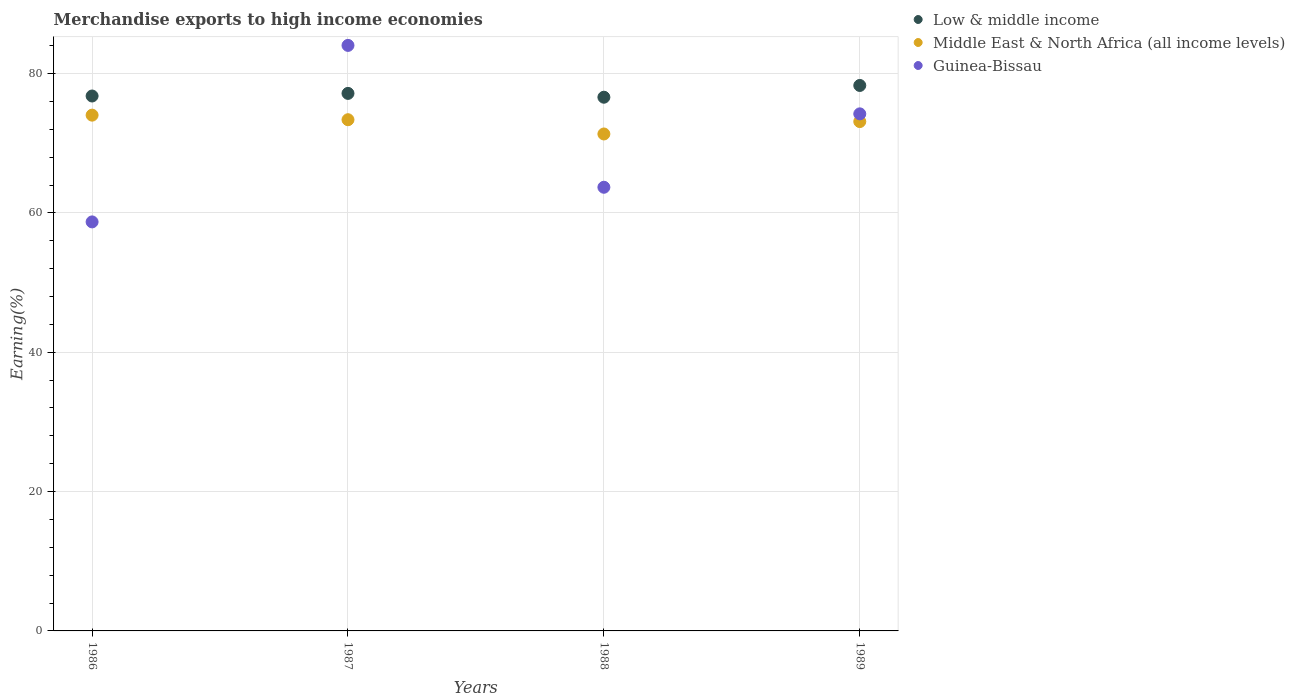How many different coloured dotlines are there?
Offer a very short reply. 3. What is the percentage of amount earned from merchandise exports in Guinea-Bissau in 1986?
Keep it short and to the point. 58.71. Across all years, what is the maximum percentage of amount earned from merchandise exports in Low & middle income?
Give a very brief answer. 78.29. Across all years, what is the minimum percentage of amount earned from merchandise exports in Middle East & North Africa (all income levels)?
Ensure brevity in your answer.  71.33. In which year was the percentage of amount earned from merchandise exports in Middle East & North Africa (all income levels) maximum?
Keep it short and to the point. 1986. What is the total percentage of amount earned from merchandise exports in Low & middle income in the graph?
Provide a succinct answer. 308.84. What is the difference between the percentage of amount earned from merchandise exports in Middle East & North Africa (all income levels) in 1986 and that in 1987?
Make the answer very short. 0.66. What is the difference between the percentage of amount earned from merchandise exports in Guinea-Bissau in 1988 and the percentage of amount earned from merchandise exports in Middle East & North Africa (all income levels) in 1987?
Offer a terse response. -9.7. What is the average percentage of amount earned from merchandise exports in Middle East & North Africa (all income levels) per year?
Offer a very short reply. 72.96. In the year 1987, what is the difference between the percentage of amount earned from merchandise exports in Guinea-Bissau and percentage of amount earned from merchandise exports in Middle East & North Africa (all income levels)?
Ensure brevity in your answer.  10.67. In how many years, is the percentage of amount earned from merchandise exports in Guinea-Bissau greater than 24 %?
Make the answer very short. 4. What is the ratio of the percentage of amount earned from merchandise exports in Low & middle income in 1986 to that in 1987?
Provide a succinct answer. 1. Is the percentage of amount earned from merchandise exports in Low & middle income in 1988 less than that in 1989?
Keep it short and to the point. Yes. What is the difference between the highest and the second highest percentage of amount earned from merchandise exports in Guinea-Bissau?
Make the answer very short. 9.83. What is the difference between the highest and the lowest percentage of amount earned from merchandise exports in Low & middle income?
Your answer should be very brief. 1.69. In how many years, is the percentage of amount earned from merchandise exports in Low & middle income greater than the average percentage of amount earned from merchandise exports in Low & middle income taken over all years?
Provide a succinct answer. 1. Is it the case that in every year, the sum of the percentage of amount earned from merchandise exports in Middle East & North Africa (all income levels) and percentage of amount earned from merchandise exports in Guinea-Bissau  is greater than the percentage of amount earned from merchandise exports in Low & middle income?
Keep it short and to the point. Yes. Does the percentage of amount earned from merchandise exports in Middle East & North Africa (all income levels) monotonically increase over the years?
Your answer should be compact. No. Is the percentage of amount earned from merchandise exports in Guinea-Bissau strictly less than the percentage of amount earned from merchandise exports in Middle East & North Africa (all income levels) over the years?
Provide a short and direct response. No. How many dotlines are there?
Offer a terse response. 3. How many years are there in the graph?
Your answer should be very brief. 4. Are the values on the major ticks of Y-axis written in scientific E-notation?
Your response must be concise. No. Does the graph contain grids?
Give a very brief answer. Yes. Where does the legend appear in the graph?
Your answer should be compact. Top right. How many legend labels are there?
Offer a very short reply. 3. How are the legend labels stacked?
Your response must be concise. Vertical. What is the title of the graph?
Keep it short and to the point. Merchandise exports to high income economies. What is the label or title of the Y-axis?
Keep it short and to the point. Earning(%). What is the Earning(%) in Low & middle income in 1986?
Provide a succinct answer. 76.78. What is the Earning(%) of Middle East & North Africa (all income levels) in 1986?
Provide a succinct answer. 74.03. What is the Earning(%) of Guinea-Bissau in 1986?
Your answer should be very brief. 58.71. What is the Earning(%) of Low & middle income in 1987?
Offer a terse response. 77.16. What is the Earning(%) of Middle East & North Africa (all income levels) in 1987?
Provide a succinct answer. 73.38. What is the Earning(%) of Guinea-Bissau in 1987?
Your response must be concise. 84.04. What is the Earning(%) of Low & middle income in 1988?
Give a very brief answer. 76.61. What is the Earning(%) in Middle East & North Africa (all income levels) in 1988?
Provide a short and direct response. 71.33. What is the Earning(%) of Guinea-Bissau in 1988?
Make the answer very short. 63.68. What is the Earning(%) of Low & middle income in 1989?
Your answer should be very brief. 78.29. What is the Earning(%) of Middle East & North Africa (all income levels) in 1989?
Keep it short and to the point. 73.11. What is the Earning(%) in Guinea-Bissau in 1989?
Your answer should be very brief. 74.22. Across all years, what is the maximum Earning(%) of Low & middle income?
Keep it short and to the point. 78.29. Across all years, what is the maximum Earning(%) of Middle East & North Africa (all income levels)?
Keep it short and to the point. 74.03. Across all years, what is the maximum Earning(%) in Guinea-Bissau?
Offer a terse response. 84.04. Across all years, what is the minimum Earning(%) in Low & middle income?
Provide a short and direct response. 76.61. Across all years, what is the minimum Earning(%) in Middle East & North Africa (all income levels)?
Give a very brief answer. 71.33. Across all years, what is the minimum Earning(%) in Guinea-Bissau?
Keep it short and to the point. 58.71. What is the total Earning(%) in Low & middle income in the graph?
Your answer should be very brief. 308.84. What is the total Earning(%) in Middle East & North Africa (all income levels) in the graph?
Provide a short and direct response. 291.85. What is the total Earning(%) of Guinea-Bissau in the graph?
Provide a short and direct response. 280.65. What is the difference between the Earning(%) of Low & middle income in 1986 and that in 1987?
Your response must be concise. -0.37. What is the difference between the Earning(%) of Middle East & North Africa (all income levels) in 1986 and that in 1987?
Give a very brief answer. 0.66. What is the difference between the Earning(%) in Guinea-Bissau in 1986 and that in 1987?
Your answer should be compact. -25.34. What is the difference between the Earning(%) in Low & middle income in 1986 and that in 1988?
Provide a succinct answer. 0.17. What is the difference between the Earning(%) in Middle East & North Africa (all income levels) in 1986 and that in 1988?
Ensure brevity in your answer.  2.7. What is the difference between the Earning(%) of Guinea-Bissau in 1986 and that in 1988?
Your response must be concise. -4.97. What is the difference between the Earning(%) in Low & middle income in 1986 and that in 1989?
Offer a very short reply. -1.51. What is the difference between the Earning(%) in Middle East & North Africa (all income levels) in 1986 and that in 1989?
Make the answer very short. 0.92. What is the difference between the Earning(%) in Guinea-Bissau in 1986 and that in 1989?
Give a very brief answer. -15.51. What is the difference between the Earning(%) of Low & middle income in 1987 and that in 1988?
Keep it short and to the point. 0.55. What is the difference between the Earning(%) in Middle East & North Africa (all income levels) in 1987 and that in 1988?
Keep it short and to the point. 2.05. What is the difference between the Earning(%) in Guinea-Bissau in 1987 and that in 1988?
Provide a succinct answer. 20.36. What is the difference between the Earning(%) of Low & middle income in 1987 and that in 1989?
Keep it short and to the point. -1.14. What is the difference between the Earning(%) of Middle East & North Africa (all income levels) in 1987 and that in 1989?
Offer a terse response. 0.27. What is the difference between the Earning(%) of Guinea-Bissau in 1987 and that in 1989?
Your answer should be very brief. 9.83. What is the difference between the Earning(%) of Low & middle income in 1988 and that in 1989?
Give a very brief answer. -1.69. What is the difference between the Earning(%) in Middle East & North Africa (all income levels) in 1988 and that in 1989?
Provide a short and direct response. -1.78. What is the difference between the Earning(%) of Guinea-Bissau in 1988 and that in 1989?
Give a very brief answer. -10.54. What is the difference between the Earning(%) in Low & middle income in 1986 and the Earning(%) in Middle East & North Africa (all income levels) in 1987?
Make the answer very short. 3.4. What is the difference between the Earning(%) in Low & middle income in 1986 and the Earning(%) in Guinea-Bissau in 1987?
Provide a short and direct response. -7.26. What is the difference between the Earning(%) of Middle East & North Africa (all income levels) in 1986 and the Earning(%) of Guinea-Bissau in 1987?
Your response must be concise. -10.01. What is the difference between the Earning(%) in Low & middle income in 1986 and the Earning(%) in Middle East & North Africa (all income levels) in 1988?
Provide a short and direct response. 5.45. What is the difference between the Earning(%) of Low & middle income in 1986 and the Earning(%) of Guinea-Bissau in 1988?
Provide a short and direct response. 13.1. What is the difference between the Earning(%) in Middle East & North Africa (all income levels) in 1986 and the Earning(%) in Guinea-Bissau in 1988?
Keep it short and to the point. 10.35. What is the difference between the Earning(%) of Low & middle income in 1986 and the Earning(%) of Middle East & North Africa (all income levels) in 1989?
Your answer should be compact. 3.67. What is the difference between the Earning(%) of Low & middle income in 1986 and the Earning(%) of Guinea-Bissau in 1989?
Keep it short and to the point. 2.56. What is the difference between the Earning(%) in Middle East & North Africa (all income levels) in 1986 and the Earning(%) in Guinea-Bissau in 1989?
Your answer should be very brief. -0.19. What is the difference between the Earning(%) of Low & middle income in 1987 and the Earning(%) of Middle East & North Africa (all income levels) in 1988?
Offer a very short reply. 5.83. What is the difference between the Earning(%) in Low & middle income in 1987 and the Earning(%) in Guinea-Bissau in 1988?
Make the answer very short. 13.47. What is the difference between the Earning(%) in Middle East & North Africa (all income levels) in 1987 and the Earning(%) in Guinea-Bissau in 1988?
Your response must be concise. 9.7. What is the difference between the Earning(%) in Low & middle income in 1987 and the Earning(%) in Middle East & North Africa (all income levels) in 1989?
Offer a terse response. 4.04. What is the difference between the Earning(%) in Low & middle income in 1987 and the Earning(%) in Guinea-Bissau in 1989?
Your response must be concise. 2.94. What is the difference between the Earning(%) of Middle East & North Africa (all income levels) in 1987 and the Earning(%) of Guinea-Bissau in 1989?
Keep it short and to the point. -0.84. What is the difference between the Earning(%) of Low & middle income in 1988 and the Earning(%) of Middle East & North Africa (all income levels) in 1989?
Keep it short and to the point. 3.5. What is the difference between the Earning(%) in Low & middle income in 1988 and the Earning(%) in Guinea-Bissau in 1989?
Your answer should be very brief. 2.39. What is the difference between the Earning(%) in Middle East & North Africa (all income levels) in 1988 and the Earning(%) in Guinea-Bissau in 1989?
Keep it short and to the point. -2.89. What is the average Earning(%) in Low & middle income per year?
Your answer should be compact. 77.21. What is the average Earning(%) of Middle East & North Africa (all income levels) per year?
Your response must be concise. 72.96. What is the average Earning(%) of Guinea-Bissau per year?
Give a very brief answer. 70.16. In the year 1986, what is the difference between the Earning(%) of Low & middle income and Earning(%) of Middle East & North Africa (all income levels)?
Your answer should be compact. 2.75. In the year 1986, what is the difference between the Earning(%) of Low & middle income and Earning(%) of Guinea-Bissau?
Give a very brief answer. 18.07. In the year 1986, what is the difference between the Earning(%) of Middle East & North Africa (all income levels) and Earning(%) of Guinea-Bissau?
Offer a very short reply. 15.32. In the year 1987, what is the difference between the Earning(%) of Low & middle income and Earning(%) of Middle East & North Africa (all income levels)?
Offer a very short reply. 3.78. In the year 1987, what is the difference between the Earning(%) in Low & middle income and Earning(%) in Guinea-Bissau?
Your answer should be very brief. -6.89. In the year 1987, what is the difference between the Earning(%) of Middle East & North Africa (all income levels) and Earning(%) of Guinea-Bissau?
Your response must be concise. -10.67. In the year 1988, what is the difference between the Earning(%) in Low & middle income and Earning(%) in Middle East & North Africa (all income levels)?
Offer a very short reply. 5.28. In the year 1988, what is the difference between the Earning(%) of Low & middle income and Earning(%) of Guinea-Bissau?
Your response must be concise. 12.92. In the year 1988, what is the difference between the Earning(%) in Middle East & North Africa (all income levels) and Earning(%) in Guinea-Bissau?
Keep it short and to the point. 7.65. In the year 1989, what is the difference between the Earning(%) in Low & middle income and Earning(%) in Middle East & North Africa (all income levels)?
Make the answer very short. 5.18. In the year 1989, what is the difference between the Earning(%) in Low & middle income and Earning(%) in Guinea-Bissau?
Your answer should be very brief. 4.08. In the year 1989, what is the difference between the Earning(%) of Middle East & North Africa (all income levels) and Earning(%) of Guinea-Bissau?
Provide a short and direct response. -1.11. What is the ratio of the Earning(%) of Middle East & North Africa (all income levels) in 1986 to that in 1987?
Your answer should be very brief. 1.01. What is the ratio of the Earning(%) in Guinea-Bissau in 1986 to that in 1987?
Give a very brief answer. 0.7. What is the ratio of the Earning(%) in Middle East & North Africa (all income levels) in 1986 to that in 1988?
Your response must be concise. 1.04. What is the ratio of the Earning(%) of Guinea-Bissau in 1986 to that in 1988?
Give a very brief answer. 0.92. What is the ratio of the Earning(%) in Low & middle income in 1986 to that in 1989?
Give a very brief answer. 0.98. What is the ratio of the Earning(%) in Middle East & North Africa (all income levels) in 1986 to that in 1989?
Your response must be concise. 1.01. What is the ratio of the Earning(%) in Guinea-Bissau in 1986 to that in 1989?
Ensure brevity in your answer.  0.79. What is the ratio of the Earning(%) of Low & middle income in 1987 to that in 1988?
Make the answer very short. 1.01. What is the ratio of the Earning(%) in Middle East & North Africa (all income levels) in 1987 to that in 1988?
Make the answer very short. 1.03. What is the ratio of the Earning(%) in Guinea-Bissau in 1987 to that in 1988?
Your response must be concise. 1.32. What is the ratio of the Earning(%) of Low & middle income in 1987 to that in 1989?
Provide a succinct answer. 0.99. What is the ratio of the Earning(%) in Middle East & North Africa (all income levels) in 1987 to that in 1989?
Provide a short and direct response. 1. What is the ratio of the Earning(%) of Guinea-Bissau in 1987 to that in 1989?
Your answer should be compact. 1.13. What is the ratio of the Earning(%) of Low & middle income in 1988 to that in 1989?
Your response must be concise. 0.98. What is the ratio of the Earning(%) of Middle East & North Africa (all income levels) in 1988 to that in 1989?
Provide a short and direct response. 0.98. What is the ratio of the Earning(%) of Guinea-Bissau in 1988 to that in 1989?
Provide a short and direct response. 0.86. What is the difference between the highest and the second highest Earning(%) in Low & middle income?
Offer a very short reply. 1.14. What is the difference between the highest and the second highest Earning(%) in Middle East & North Africa (all income levels)?
Your answer should be compact. 0.66. What is the difference between the highest and the second highest Earning(%) in Guinea-Bissau?
Your answer should be compact. 9.83. What is the difference between the highest and the lowest Earning(%) in Low & middle income?
Keep it short and to the point. 1.69. What is the difference between the highest and the lowest Earning(%) of Middle East & North Africa (all income levels)?
Your answer should be very brief. 2.7. What is the difference between the highest and the lowest Earning(%) of Guinea-Bissau?
Provide a short and direct response. 25.34. 